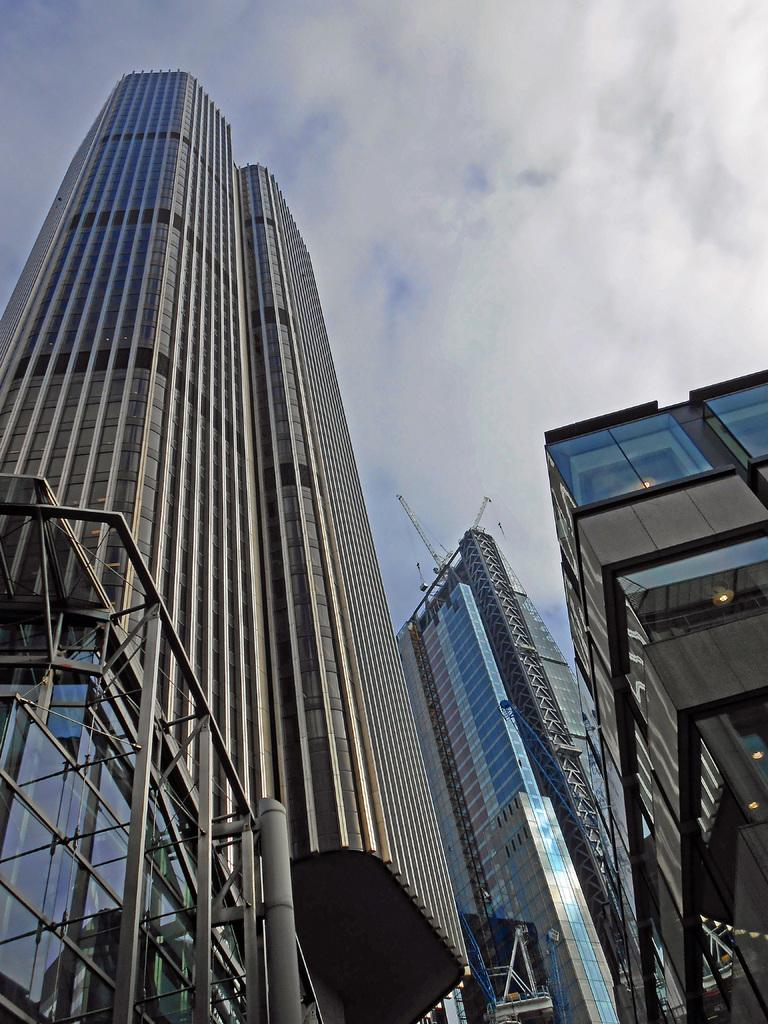What type of buildings can be seen in the image? There are many buildings made up of glass in the image. How would you describe the weather based on the image? The sky is cloudy in the image. Can you identify any sources of light in the image? Yes, there are lights visible in the image. What type of collar can be seen on the mice in the image? There are no mice or collars present in the image. What topics are being discussed by the people in the image? There are no people or discussions visible in the image. 